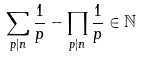<formula> <loc_0><loc_0><loc_500><loc_500>\sum _ { p | n } \frac { 1 } { p } - \prod _ { p | n } \frac { 1 } { p } \in \mathbb { N }</formula> 